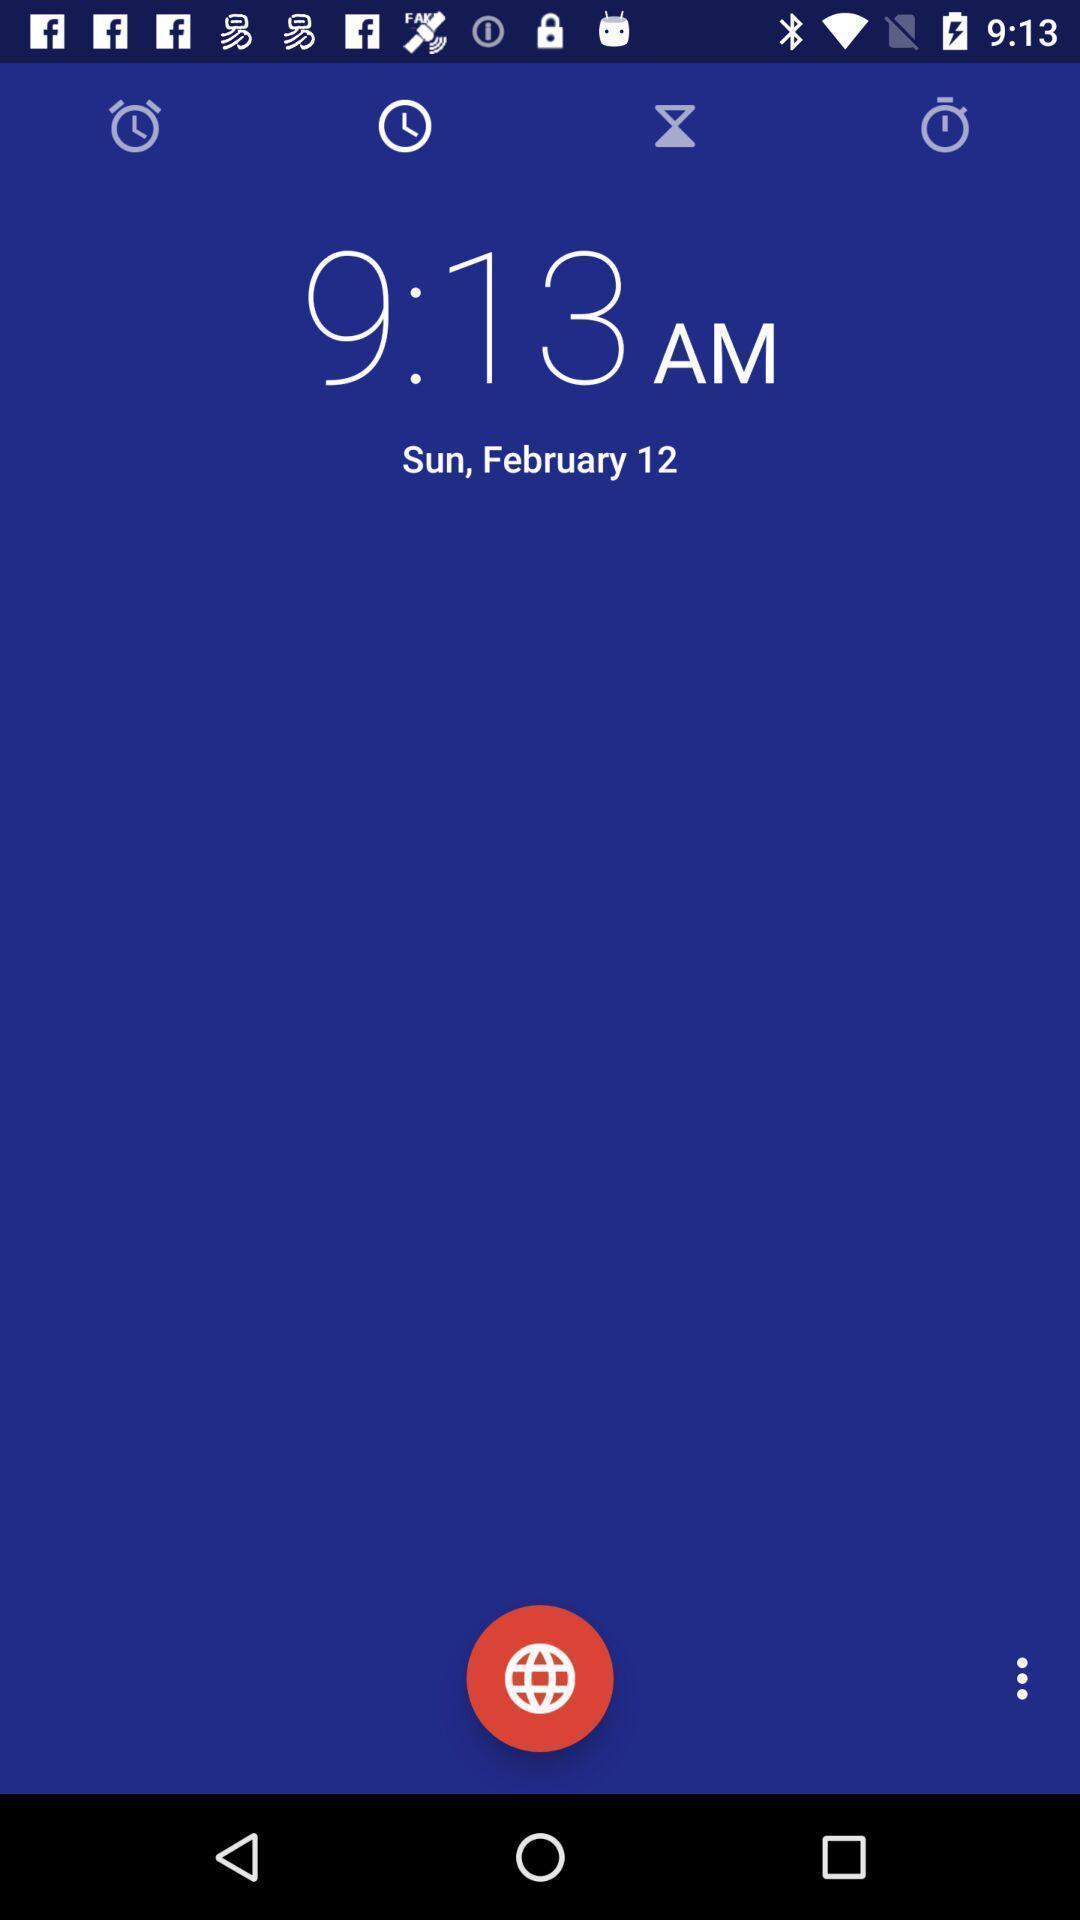Provide a textual representation of this image. Screen displaying time with date. 